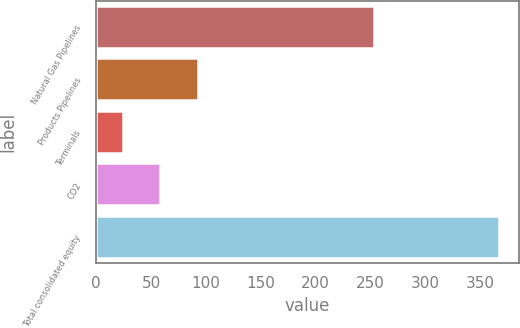Convert chart. <chart><loc_0><loc_0><loc_500><loc_500><bar_chart><fcel>Natural Gas Pipelines<fcel>Products Pipelines<fcel>Terminals<fcel>CO2<fcel>Total consolidated equity<nl><fcel>253<fcel>92.6<fcel>24<fcel>58.3<fcel>367<nl></chart> 